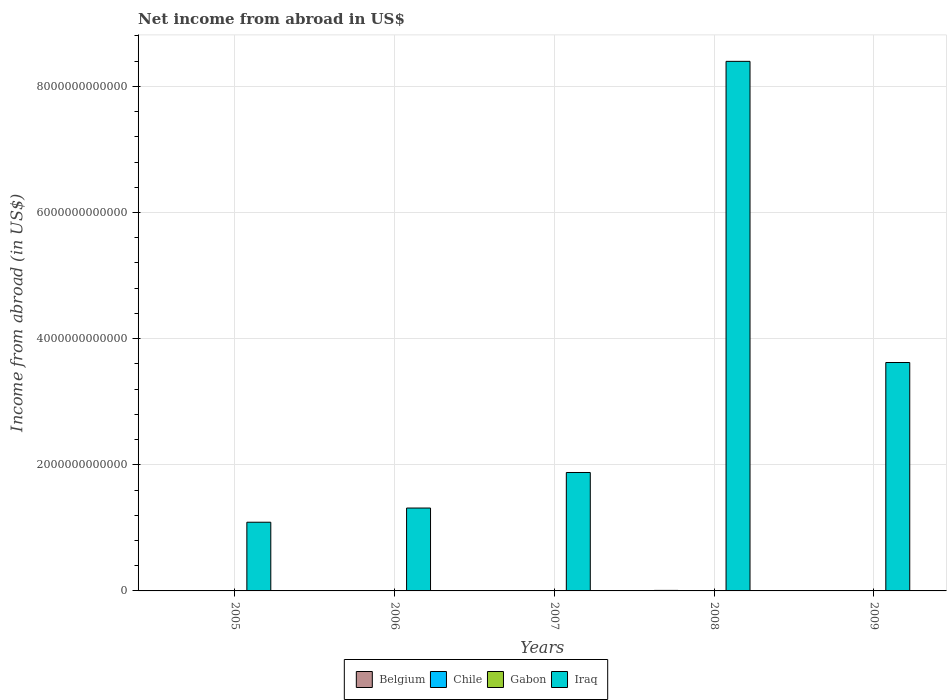How many groups of bars are there?
Provide a succinct answer. 5. Are the number of bars per tick equal to the number of legend labels?
Ensure brevity in your answer.  No. Are the number of bars on each tick of the X-axis equal?
Your response must be concise. Yes. How many bars are there on the 3rd tick from the left?
Your response must be concise. 2. What is the label of the 1st group of bars from the left?
Your answer should be very brief. 2005. Across all years, what is the maximum net income from abroad in Belgium?
Provide a succinct answer. 8.30e+09. Across all years, what is the minimum net income from abroad in Belgium?
Offer a very short reply. 4.30e+08. In which year was the net income from abroad in Belgium maximum?
Provide a short and direct response. 2008. What is the total net income from abroad in Chile in the graph?
Your answer should be compact. 0. What is the difference between the net income from abroad in Belgium in 2006 and that in 2009?
Offer a terse response. 4.00e+09. What is the average net income from abroad in Gabon per year?
Provide a short and direct response. 0. In the year 2008, what is the difference between the net income from abroad in Iraq and net income from abroad in Belgium?
Provide a succinct answer. 8.39e+12. In how many years, is the net income from abroad in Belgium greater than 7200000000000 US$?
Your response must be concise. 0. What is the ratio of the net income from abroad in Belgium in 2005 to that in 2007?
Ensure brevity in your answer.  0.81. Is the net income from abroad in Belgium in 2006 less than that in 2009?
Your answer should be very brief. No. What is the difference between the highest and the second highest net income from abroad in Belgium?
Offer a terse response. 3.78e+09. What is the difference between the highest and the lowest net income from abroad in Iraq?
Provide a short and direct response. 7.31e+12. In how many years, is the net income from abroad in Gabon greater than the average net income from abroad in Gabon taken over all years?
Offer a very short reply. 0. Is the sum of the net income from abroad in Iraq in 2005 and 2009 greater than the maximum net income from abroad in Belgium across all years?
Give a very brief answer. Yes. How many bars are there?
Provide a succinct answer. 10. What is the difference between two consecutive major ticks on the Y-axis?
Make the answer very short. 2.00e+12. Are the values on the major ticks of Y-axis written in scientific E-notation?
Give a very brief answer. No. Does the graph contain any zero values?
Make the answer very short. Yes. Does the graph contain grids?
Offer a very short reply. Yes. Where does the legend appear in the graph?
Provide a short and direct response. Bottom center. What is the title of the graph?
Offer a very short reply. Net income from abroad in US$. Does "Central African Republic" appear as one of the legend labels in the graph?
Your response must be concise. No. What is the label or title of the Y-axis?
Provide a short and direct response. Income from abroad (in US$). What is the Income from abroad (in US$) in Belgium in 2005?
Provide a short and direct response. 3.65e+09. What is the Income from abroad (in US$) in Chile in 2005?
Keep it short and to the point. 0. What is the Income from abroad (in US$) in Gabon in 2005?
Provide a succinct answer. 0. What is the Income from abroad (in US$) in Iraq in 2005?
Your answer should be compact. 1.09e+12. What is the Income from abroad (in US$) of Belgium in 2006?
Your answer should be very brief. 4.43e+09. What is the Income from abroad (in US$) in Chile in 2006?
Keep it short and to the point. 0. What is the Income from abroad (in US$) of Iraq in 2006?
Ensure brevity in your answer.  1.31e+12. What is the Income from abroad (in US$) of Belgium in 2007?
Your response must be concise. 4.52e+09. What is the Income from abroad (in US$) of Chile in 2007?
Your response must be concise. 0. What is the Income from abroad (in US$) in Gabon in 2007?
Offer a terse response. 0. What is the Income from abroad (in US$) in Iraq in 2007?
Provide a succinct answer. 1.88e+12. What is the Income from abroad (in US$) of Belgium in 2008?
Offer a terse response. 8.30e+09. What is the Income from abroad (in US$) of Chile in 2008?
Offer a very short reply. 0. What is the Income from abroad (in US$) of Iraq in 2008?
Give a very brief answer. 8.40e+12. What is the Income from abroad (in US$) in Belgium in 2009?
Provide a short and direct response. 4.30e+08. What is the Income from abroad (in US$) of Chile in 2009?
Your answer should be compact. 0. What is the Income from abroad (in US$) in Iraq in 2009?
Your answer should be compact. 3.62e+12. Across all years, what is the maximum Income from abroad (in US$) in Belgium?
Your response must be concise. 8.30e+09. Across all years, what is the maximum Income from abroad (in US$) of Iraq?
Keep it short and to the point. 8.40e+12. Across all years, what is the minimum Income from abroad (in US$) of Belgium?
Make the answer very short. 4.30e+08. Across all years, what is the minimum Income from abroad (in US$) in Iraq?
Keep it short and to the point. 1.09e+12. What is the total Income from abroad (in US$) of Belgium in the graph?
Ensure brevity in your answer.  2.13e+1. What is the total Income from abroad (in US$) in Chile in the graph?
Offer a terse response. 0. What is the total Income from abroad (in US$) of Gabon in the graph?
Keep it short and to the point. 0. What is the total Income from abroad (in US$) in Iraq in the graph?
Ensure brevity in your answer.  1.63e+13. What is the difference between the Income from abroad (in US$) in Belgium in 2005 and that in 2006?
Your answer should be very brief. -7.78e+08. What is the difference between the Income from abroad (in US$) in Iraq in 2005 and that in 2006?
Make the answer very short. -2.25e+11. What is the difference between the Income from abroad (in US$) of Belgium in 2005 and that in 2007?
Offer a terse response. -8.69e+08. What is the difference between the Income from abroad (in US$) in Iraq in 2005 and that in 2007?
Provide a succinct answer. -7.88e+11. What is the difference between the Income from abroad (in US$) of Belgium in 2005 and that in 2008?
Give a very brief answer. -4.65e+09. What is the difference between the Income from abroad (in US$) in Iraq in 2005 and that in 2008?
Keep it short and to the point. -7.31e+12. What is the difference between the Income from abroad (in US$) of Belgium in 2005 and that in 2009?
Your response must be concise. 3.22e+09. What is the difference between the Income from abroad (in US$) in Iraq in 2005 and that in 2009?
Your response must be concise. -2.53e+12. What is the difference between the Income from abroad (in US$) in Belgium in 2006 and that in 2007?
Give a very brief answer. -9.12e+07. What is the difference between the Income from abroad (in US$) of Iraq in 2006 and that in 2007?
Your answer should be compact. -5.63e+11. What is the difference between the Income from abroad (in US$) of Belgium in 2006 and that in 2008?
Your response must be concise. -3.87e+09. What is the difference between the Income from abroad (in US$) of Iraq in 2006 and that in 2008?
Your response must be concise. -7.08e+12. What is the difference between the Income from abroad (in US$) of Belgium in 2006 and that in 2009?
Your answer should be very brief. 4.00e+09. What is the difference between the Income from abroad (in US$) in Iraq in 2006 and that in 2009?
Keep it short and to the point. -2.31e+12. What is the difference between the Income from abroad (in US$) in Belgium in 2007 and that in 2008?
Keep it short and to the point. -3.78e+09. What is the difference between the Income from abroad (in US$) in Iraq in 2007 and that in 2008?
Keep it short and to the point. -6.52e+12. What is the difference between the Income from abroad (in US$) in Belgium in 2007 and that in 2009?
Provide a short and direct response. 4.09e+09. What is the difference between the Income from abroad (in US$) in Iraq in 2007 and that in 2009?
Make the answer very short. -1.74e+12. What is the difference between the Income from abroad (in US$) of Belgium in 2008 and that in 2009?
Your answer should be compact. 7.87e+09. What is the difference between the Income from abroad (in US$) in Iraq in 2008 and that in 2009?
Provide a succinct answer. 4.77e+12. What is the difference between the Income from abroad (in US$) in Belgium in 2005 and the Income from abroad (in US$) in Iraq in 2006?
Keep it short and to the point. -1.31e+12. What is the difference between the Income from abroad (in US$) of Belgium in 2005 and the Income from abroad (in US$) of Iraq in 2007?
Ensure brevity in your answer.  -1.87e+12. What is the difference between the Income from abroad (in US$) of Belgium in 2005 and the Income from abroad (in US$) of Iraq in 2008?
Your response must be concise. -8.39e+12. What is the difference between the Income from abroad (in US$) of Belgium in 2005 and the Income from abroad (in US$) of Iraq in 2009?
Your answer should be compact. -3.62e+12. What is the difference between the Income from abroad (in US$) of Belgium in 2006 and the Income from abroad (in US$) of Iraq in 2007?
Provide a short and direct response. -1.87e+12. What is the difference between the Income from abroad (in US$) in Belgium in 2006 and the Income from abroad (in US$) in Iraq in 2008?
Make the answer very short. -8.39e+12. What is the difference between the Income from abroad (in US$) of Belgium in 2006 and the Income from abroad (in US$) of Iraq in 2009?
Provide a succinct answer. -3.62e+12. What is the difference between the Income from abroad (in US$) of Belgium in 2007 and the Income from abroad (in US$) of Iraq in 2008?
Keep it short and to the point. -8.39e+12. What is the difference between the Income from abroad (in US$) of Belgium in 2007 and the Income from abroad (in US$) of Iraq in 2009?
Provide a short and direct response. -3.62e+12. What is the difference between the Income from abroad (in US$) of Belgium in 2008 and the Income from abroad (in US$) of Iraq in 2009?
Provide a succinct answer. -3.61e+12. What is the average Income from abroad (in US$) of Belgium per year?
Offer a terse response. 4.27e+09. What is the average Income from abroad (in US$) in Chile per year?
Provide a succinct answer. 0. What is the average Income from abroad (in US$) in Iraq per year?
Offer a very short reply. 3.26e+12. In the year 2005, what is the difference between the Income from abroad (in US$) of Belgium and Income from abroad (in US$) of Iraq?
Ensure brevity in your answer.  -1.09e+12. In the year 2006, what is the difference between the Income from abroad (in US$) in Belgium and Income from abroad (in US$) in Iraq?
Your answer should be compact. -1.31e+12. In the year 2007, what is the difference between the Income from abroad (in US$) in Belgium and Income from abroad (in US$) in Iraq?
Your response must be concise. -1.87e+12. In the year 2008, what is the difference between the Income from abroad (in US$) in Belgium and Income from abroad (in US$) in Iraq?
Make the answer very short. -8.39e+12. In the year 2009, what is the difference between the Income from abroad (in US$) in Belgium and Income from abroad (in US$) in Iraq?
Your answer should be compact. -3.62e+12. What is the ratio of the Income from abroad (in US$) of Belgium in 2005 to that in 2006?
Your response must be concise. 0.82. What is the ratio of the Income from abroad (in US$) in Iraq in 2005 to that in 2006?
Give a very brief answer. 0.83. What is the ratio of the Income from abroad (in US$) in Belgium in 2005 to that in 2007?
Keep it short and to the point. 0.81. What is the ratio of the Income from abroad (in US$) of Iraq in 2005 to that in 2007?
Provide a succinct answer. 0.58. What is the ratio of the Income from abroad (in US$) of Belgium in 2005 to that in 2008?
Offer a terse response. 0.44. What is the ratio of the Income from abroad (in US$) in Iraq in 2005 to that in 2008?
Ensure brevity in your answer.  0.13. What is the ratio of the Income from abroad (in US$) of Belgium in 2005 to that in 2009?
Make the answer very short. 8.5. What is the ratio of the Income from abroad (in US$) in Iraq in 2005 to that in 2009?
Your response must be concise. 0.3. What is the ratio of the Income from abroad (in US$) of Belgium in 2006 to that in 2007?
Ensure brevity in your answer.  0.98. What is the ratio of the Income from abroad (in US$) in Iraq in 2006 to that in 2007?
Ensure brevity in your answer.  0.7. What is the ratio of the Income from abroad (in US$) of Belgium in 2006 to that in 2008?
Make the answer very short. 0.53. What is the ratio of the Income from abroad (in US$) in Iraq in 2006 to that in 2008?
Your answer should be compact. 0.16. What is the ratio of the Income from abroad (in US$) of Belgium in 2006 to that in 2009?
Ensure brevity in your answer.  10.31. What is the ratio of the Income from abroad (in US$) of Iraq in 2006 to that in 2009?
Give a very brief answer. 0.36. What is the ratio of the Income from abroad (in US$) in Belgium in 2007 to that in 2008?
Keep it short and to the point. 0.54. What is the ratio of the Income from abroad (in US$) of Iraq in 2007 to that in 2008?
Provide a succinct answer. 0.22. What is the ratio of the Income from abroad (in US$) in Belgium in 2007 to that in 2009?
Your answer should be very brief. 10.52. What is the ratio of the Income from abroad (in US$) of Iraq in 2007 to that in 2009?
Make the answer very short. 0.52. What is the ratio of the Income from abroad (in US$) in Belgium in 2008 to that in 2009?
Give a very brief answer. 19.31. What is the ratio of the Income from abroad (in US$) of Iraq in 2008 to that in 2009?
Provide a succinct answer. 2.32. What is the difference between the highest and the second highest Income from abroad (in US$) of Belgium?
Give a very brief answer. 3.78e+09. What is the difference between the highest and the second highest Income from abroad (in US$) of Iraq?
Provide a succinct answer. 4.77e+12. What is the difference between the highest and the lowest Income from abroad (in US$) in Belgium?
Provide a short and direct response. 7.87e+09. What is the difference between the highest and the lowest Income from abroad (in US$) in Iraq?
Provide a succinct answer. 7.31e+12. 